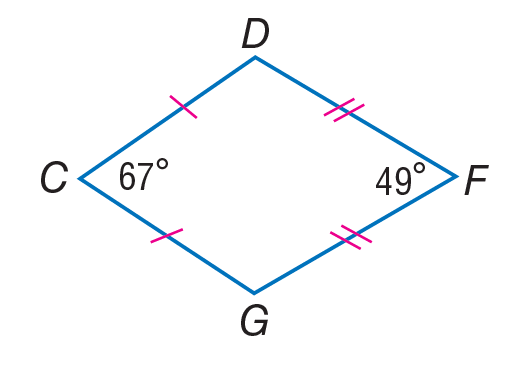Question: If C D F G is a kite, find m \angle D.
Choices:
A. 18
B. 49
C. 67
D. 122
Answer with the letter. Answer: D 